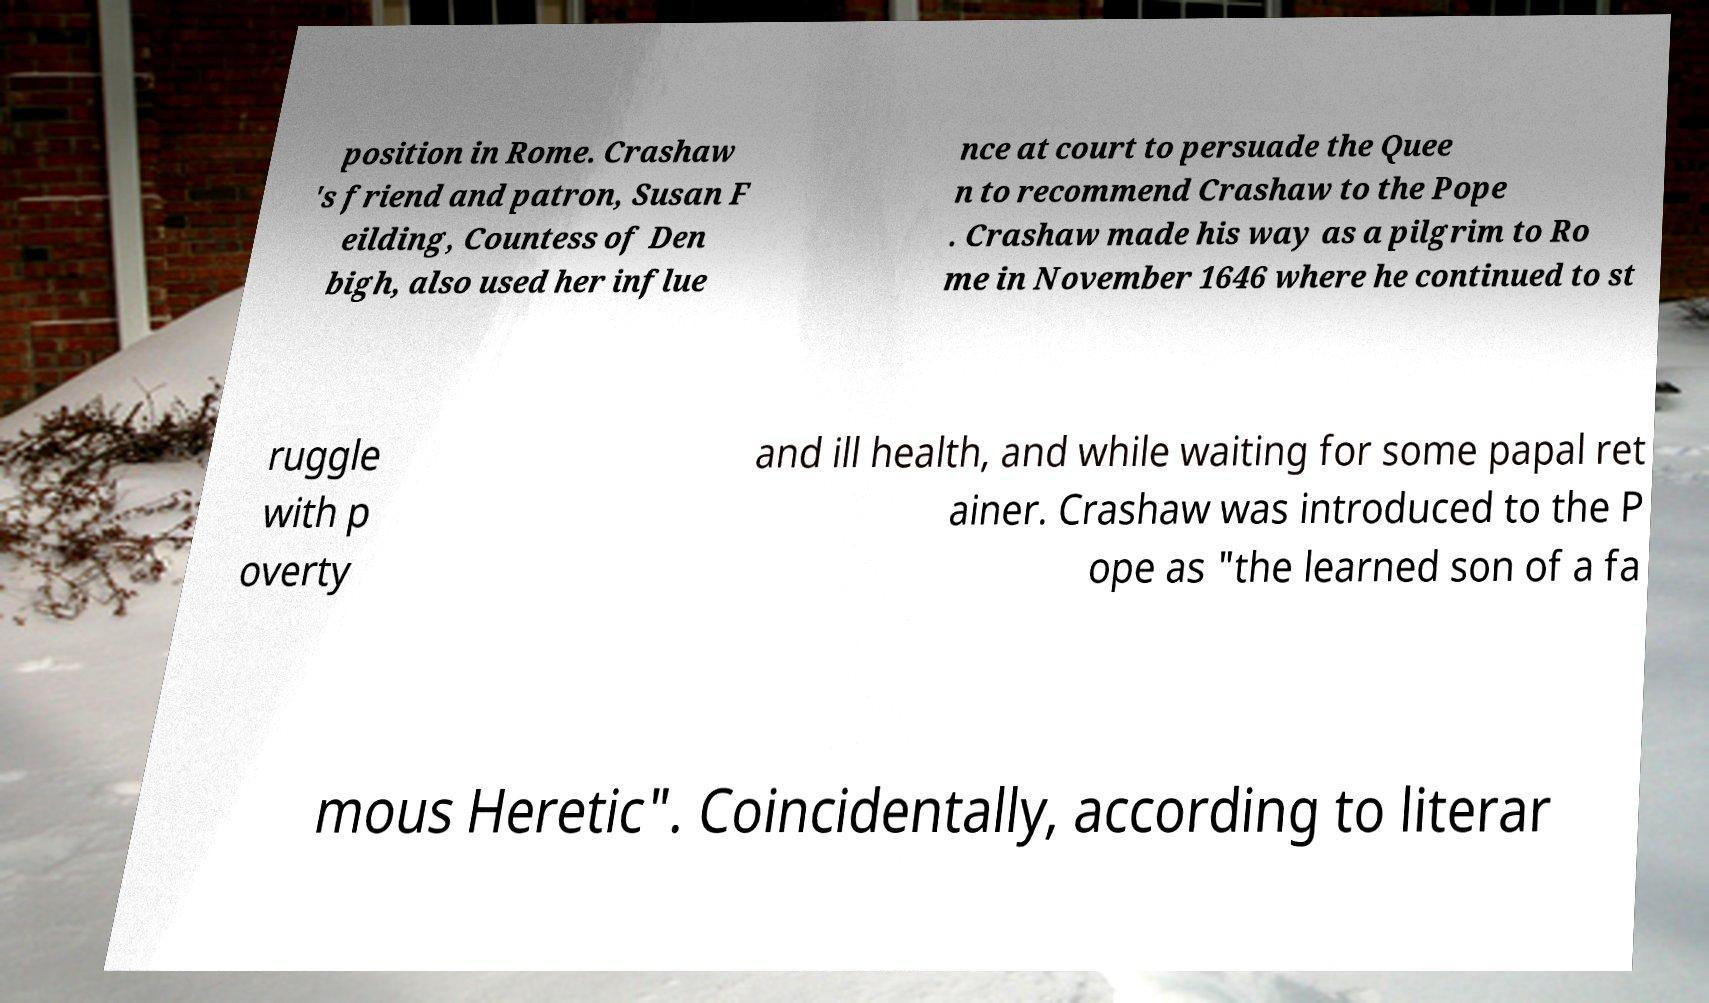For documentation purposes, I need the text within this image transcribed. Could you provide that? position in Rome. Crashaw 's friend and patron, Susan F eilding, Countess of Den bigh, also used her influe nce at court to persuade the Quee n to recommend Crashaw to the Pope . Crashaw made his way as a pilgrim to Ro me in November 1646 where he continued to st ruggle with p overty and ill health, and while waiting for some papal ret ainer. Crashaw was introduced to the P ope as "the learned son of a fa mous Heretic". Coincidentally, according to literar 